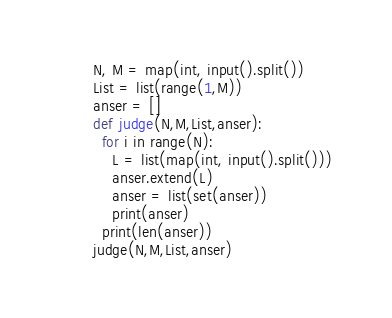Convert code to text. <code><loc_0><loc_0><loc_500><loc_500><_Python_>N, M = map(int, input().split())
List = list(range(1,M))
anser = []
def judge(N,M,List,anser):
  for i in range(N):
    L = list(map(int, input().split()))
    anser.extend(L)
    anser = list(set(anser))
    print(anser)
  print(len(anser))
judge(N,M,List,anser)</code> 